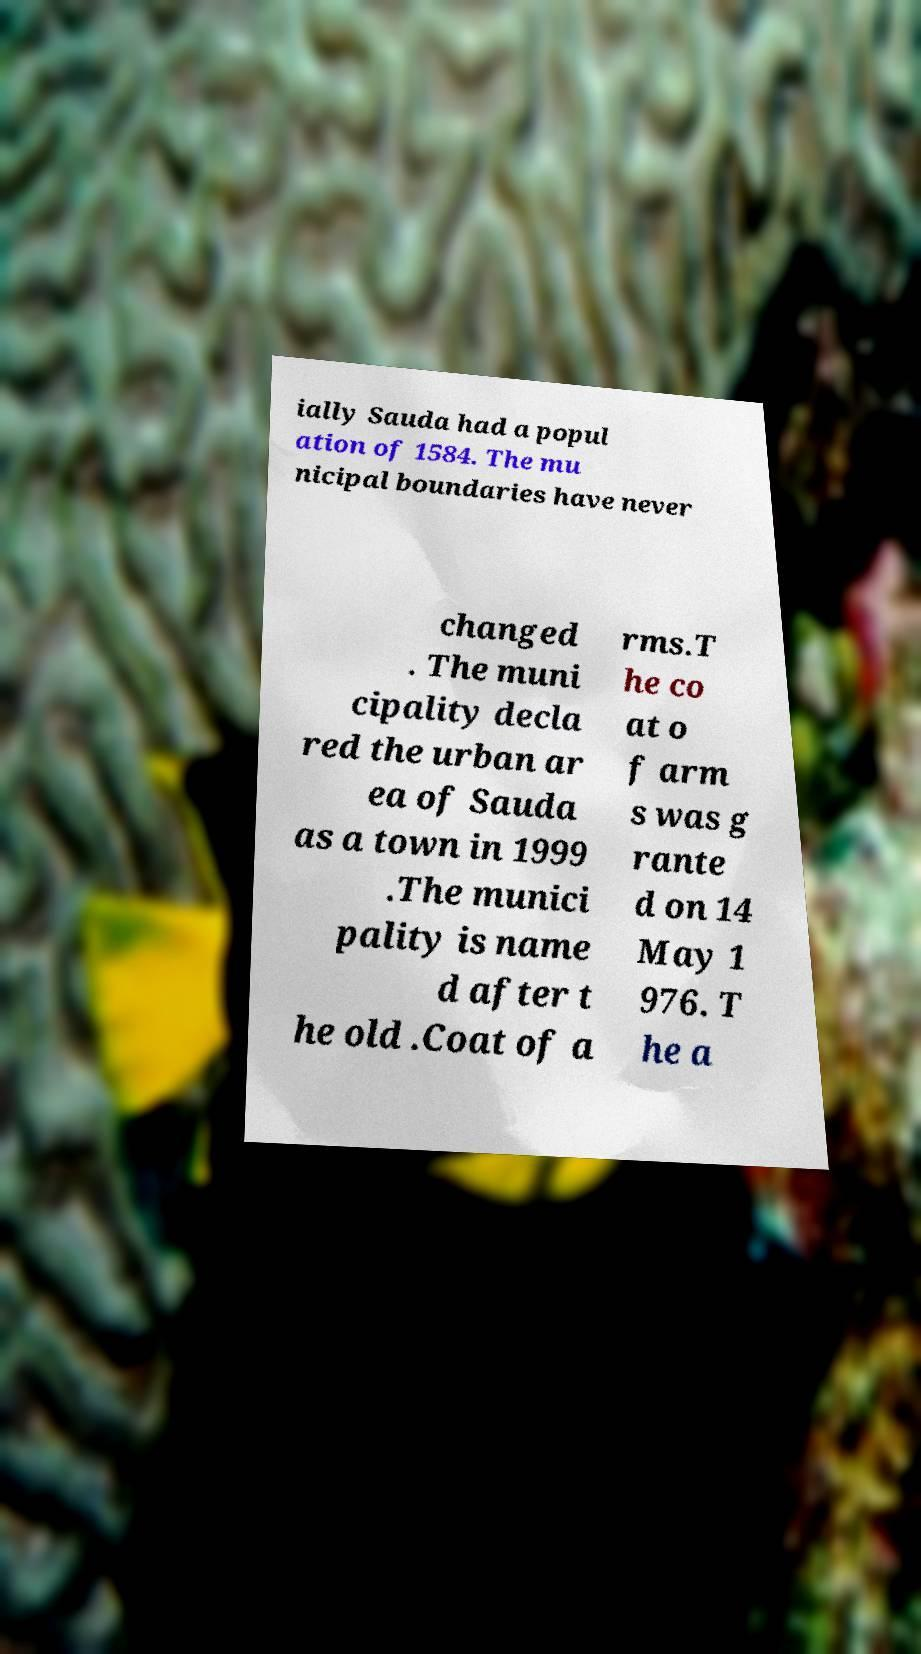For documentation purposes, I need the text within this image transcribed. Could you provide that? ially Sauda had a popul ation of 1584. The mu nicipal boundaries have never changed . The muni cipality decla red the urban ar ea of Sauda as a town in 1999 .The munici pality is name d after t he old .Coat of a rms.T he co at o f arm s was g rante d on 14 May 1 976. T he a 